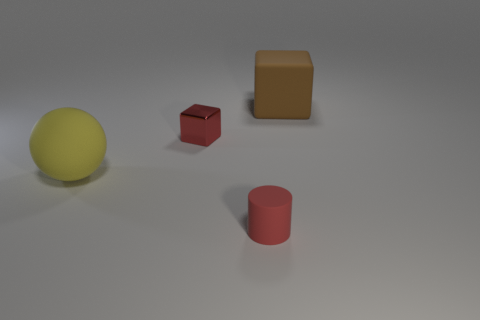Add 4 small red matte objects. How many objects exist? 8 Subtract all cylinders. How many objects are left? 3 Subtract all large yellow rubber balls. Subtract all small red matte things. How many objects are left? 2 Add 4 large rubber blocks. How many large rubber blocks are left? 5 Add 3 red cylinders. How many red cylinders exist? 4 Subtract 1 red cylinders. How many objects are left? 3 